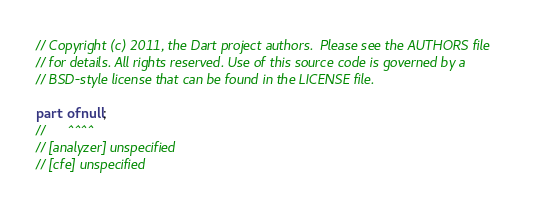Convert code to text. <code><loc_0><loc_0><loc_500><loc_500><_Dart_>// Copyright (c) 2011, the Dart project authors.  Please see the AUTHORS file
// for details. All rights reserved. Use of this source code is governed by a
// BSD-style license that can be found in the LICENSE file.

part of null;
//      ^^^^
// [analyzer] unspecified
// [cfe] unspecified</code> 